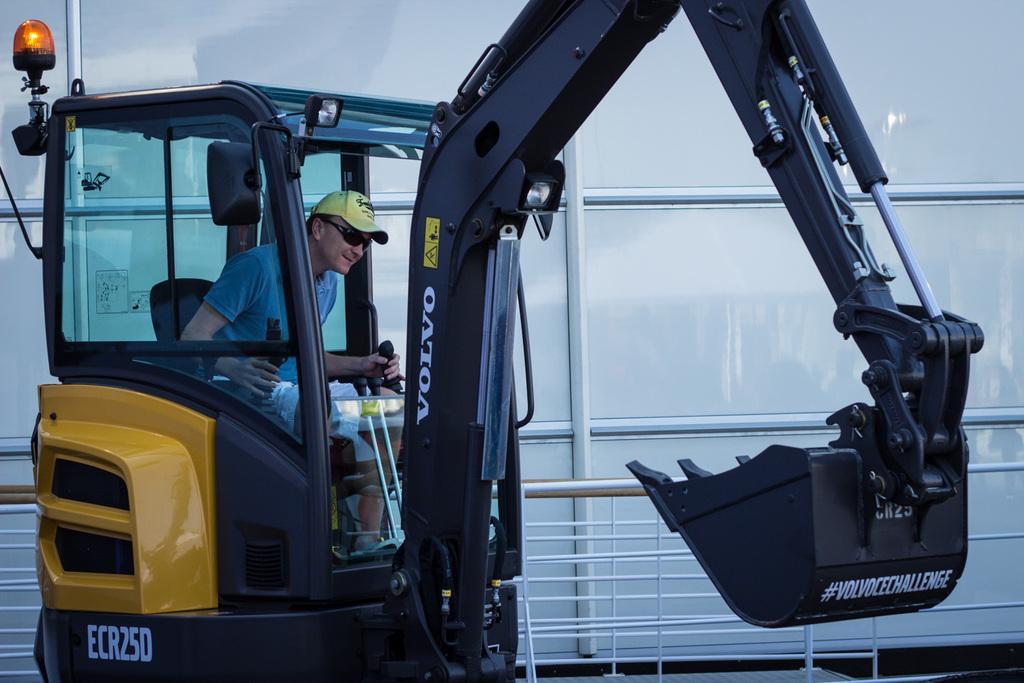How would you summarize this image in a sentence or two? Here we can see a person inside an excavator. He has goggles and he wore a cap. This is a light. In the background we can see glasses and a fence. 